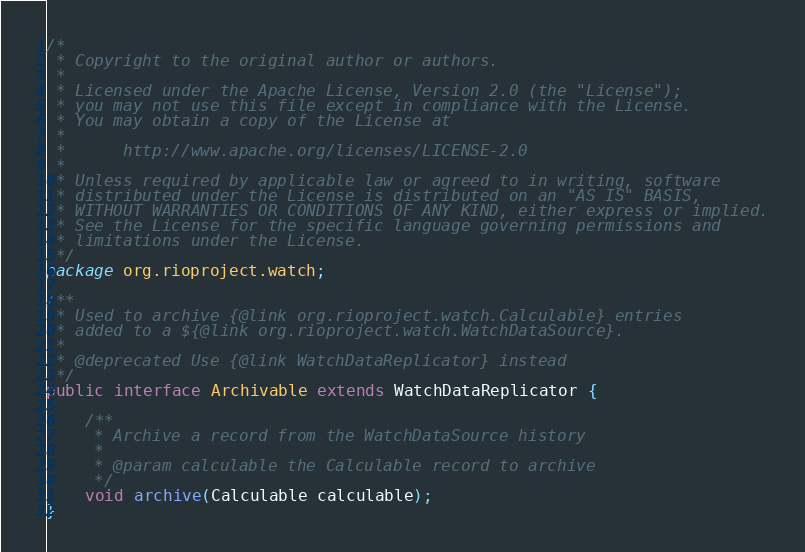Convert code to text. <code><loc_0><loc_0><loc_500><loc_500><_Java_>/*
 * Copyright to the original author or authors.
 *
 * Licensed under the Apache License, Version 2.0 (the "License");
 * you may not use this file except in compliance with the License.
 * You may obtain a copy of the License at
 *
 *      http://www.apache.org/licenses/LICENSE-2.0
 *
 * Unless required by applicable law or agreed to in writing, software
 * distributed under the License is distributed on an "AS IS" BASIS,
 * WITHOUT WARRANTIES OR CONDITIONS OF ANY KIND, either express or implied.
 * See the License for the specific language governing permissions and
 * limitations under the License.
 */
package org.rioproject.watch;

/**
 * Used to archive {@link org.rioproject.watch.Calculable} entries
 * added to a ${@link org.rioproject.watch.WatchDataSource}.
 *
 * @deprecated Use {@link WatchDataReplicator} instead
 */
public interface Archivable extends WatchDataReplicator {

    /**
     * Archive a record from the WatchDataSource history
     * 
     * @param calculable the Calculable record to archive
     */
    void archive(Calculable calculable);
}
</code> 